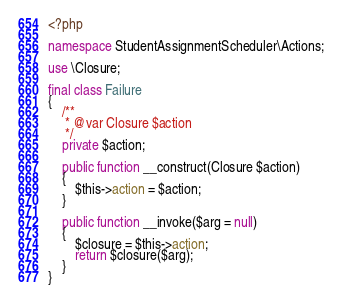Convert code to text. <code><loc_0><loc_0><loc_500><loc_500><_PHP_><?php

namespace StudentAssignmentScheduler\Actions;

use \Closure;

final class Failure
{
    /**
     * @var Closure $action
     */
    private $action;

    public function __construct(Closure $action)
    {
        $this->action = $action;
    }

    public function __invoke($arg = null)
    {
        $closure = $this->action;
        return $closure($arg);
    }
}
</code> 